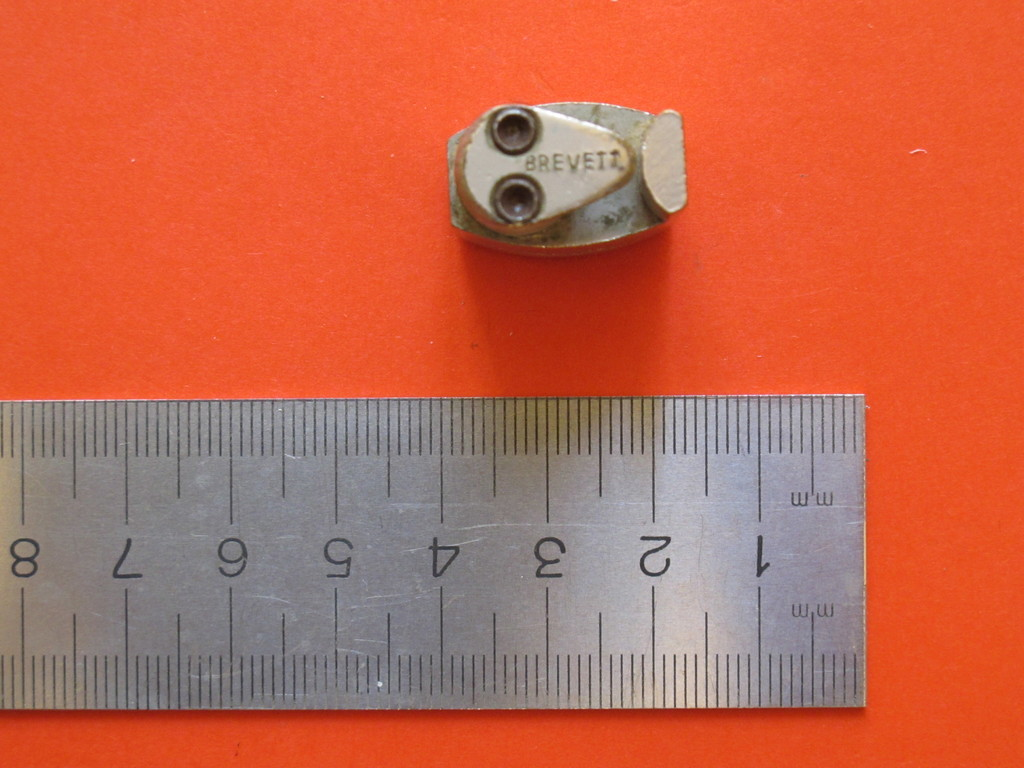What could be the possible uses for the metal object shown? The metal object, marked 'BREVEIZ', might be a specialized tool part or a component for a larger machinery, possibly used in settings where precise adjustments are critical. 